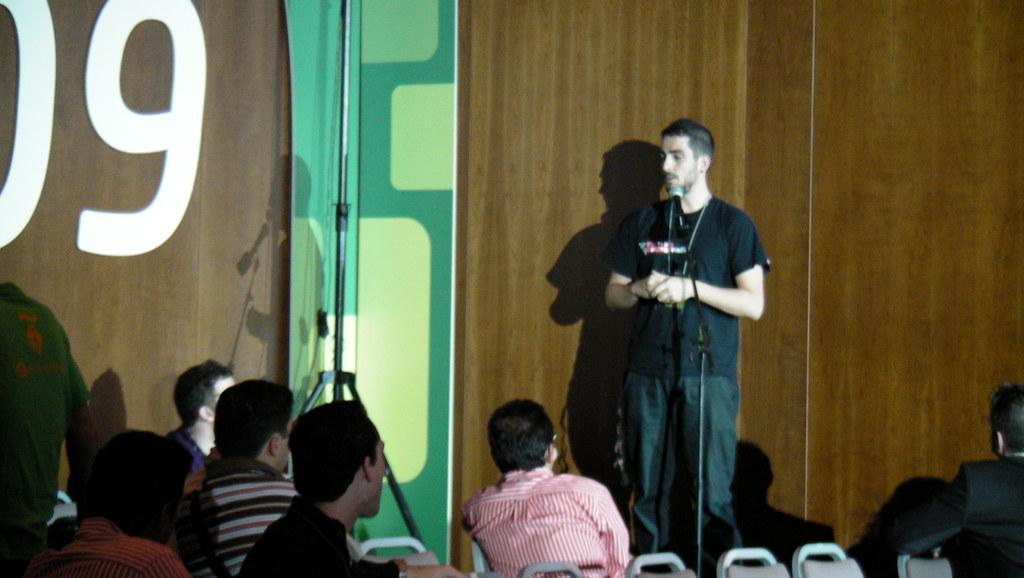How would you summarize this image in a sentence or two? In this image we can see few people sitting on chairs. In the back there is a person standing. In front of him there is a mic with mic stand. In the background there is a wall with something written. Also we can see a stand. 